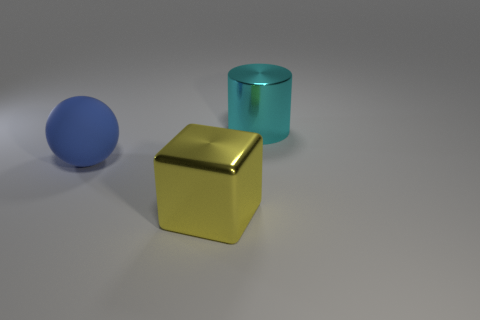Add 1 cylinders. How many objects exist? 4 Subtract all cylinders. How many objects are left? 2 Subtract all gray rubber objects. Subtract all blue matte things. How many objects are left? 2 Add 2 cylinders. How many cylinders are left? 3 Add 3 yellow cubes. How many yellow cubes exist? 4 Subtract 0 cyan blocks. How many objects are left? 3 